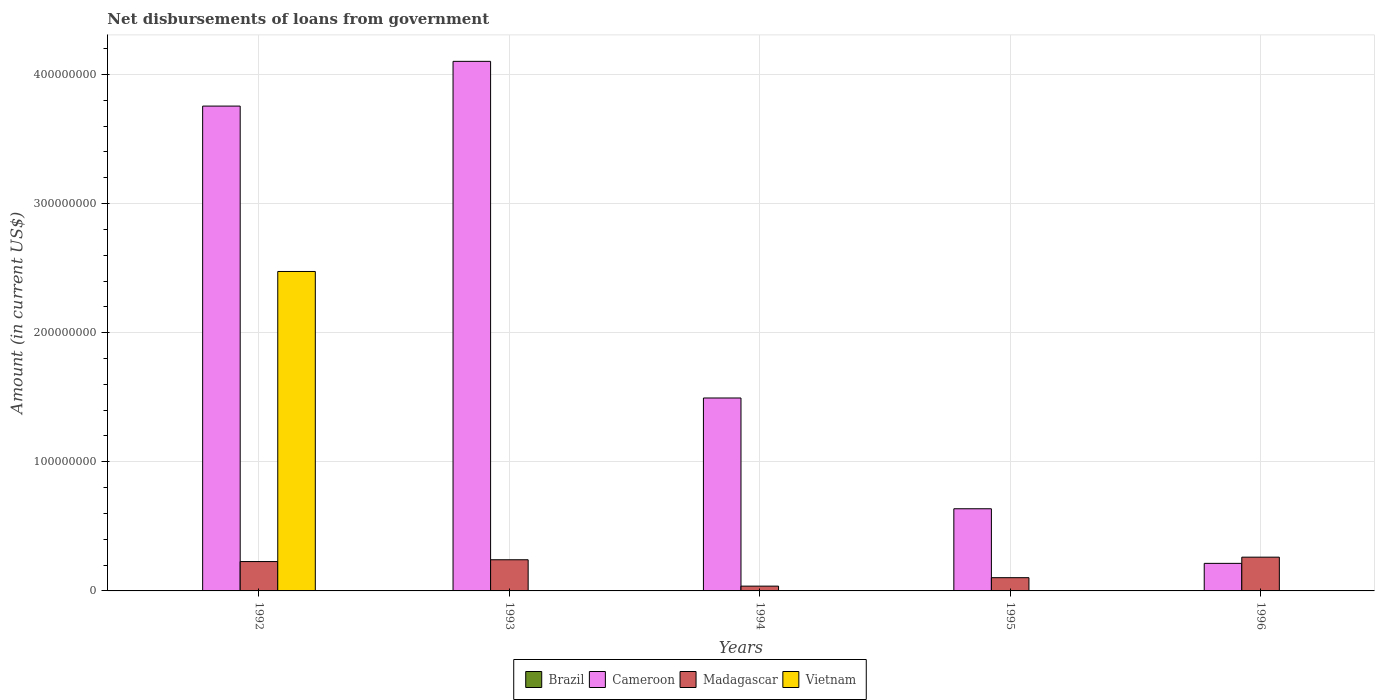Are the number of bars per tick equal to the number of legend labels?
Ensure brevity in your answer.  No. How many bars are there on the 4th tick from the left?
Provide a short and direct response. 2. How many bars are there on the 3rd tick from the right?
Keep it short and to the point. 2. What is the label of the 5th group of bars from the left?
Provide a succinct answer. 1996. In how many cases, is the number of bars for a given year not equal to the number of legend labels?
Provide a succinct answer. 5. What is the amount of loan disbursed from government in Madagascar in 1996?
Keep it short and to the point. 2.61e+07. Across all years, what is the maximum amount of loan disbursed from government in Vietnam?
Your response must be concise. 2.47e+08. Across all years, what is the minimum amount of loan disbursed from government in Brazil?
Offer a terse response. 0. In which year was the amount of loan disbursed from government in Vietnam maximum?
Make the answer very short. 1992. What is the total amount of loan disbursed from government in Vietnam in the graph?
Provide a succinct answer. 2.47e+08. What is the difference between the amount of loan disbursed from government in Cameroon in 1994 and that in 1995?
Give a very brief answer. 8.58e+07. What is the difference between the amount of loan disbursed from government in Cameroon in 1992 and the amount of loan disbursed from government in Vietnam in 1996?
Your response must be concise. 3.75e+08. What is the average amount of loan disbursed from government in Cameroon per year?
Your answer should be very brief. 2.04e+08. In the year 1992, what is the difference between the amount of loan disbursed from government in Cameroon and amount of loan disbursed from government in Vietnam?
Your response must be concise. 1.28e+08. What is the ratio of the amount of loan disbursed from government in Cameroon in 1992 to that in 1996?
Your response must be concise. 17.6. What is the difference between the highest and the second highest amount of loan disbursed from government in Madagascar?
Give a very brief answer. 2.00e+06. What is the difference between the highest and the lowest amount of loan disbursed from government in Cameroon?
Offer a terse response. 3.89e+08. In how many years, is the amount of loan disbursed from government in Vietnam greater than the average amount of loan disbursed from government in Vietnam taken over all years?
Provide a succinct answer. 1. Is it the case that in every year, the sum of the amount of loan disbursed from government in Vietnam and amount of loan disbursed from government in Brazil is greater than the amount of loan disbursed from government in Madagascar?
Your response must be concise. No. How many bars are there?
Make the answer very short. 11. Are all the bars in the graph horizontal?
Provide a short and direct response. No. How many years are there in the graph?
Give a very brief answer. 5. What is the difference between two consecutive major ticks on the Y-axis?
Provide a short and direct response. 1.00e+08. Does the graph contain any zero values?
Ensure brevity in your answer.  Yes. How are the legend labels stacked?
Your answer should be compact. Horizontal. What is the title of the graph?
Your answer should be very brief. Net disbursements of loans from government. What is the label or title of the X-axis?
Make the answer very short. Years. What is the Amount (in current US$) of Cameroon in 1992?
Keep it short and to the point. 3.75e+08. What is the Amount (in current US$) in Madagascar in 1992?
Keep it short and to the point. 2.27e+07. What is the Amount (in current US$) in Vietnam in 1992?
Give a very brief answer. 2.47e+08. What is the Amount (in current US$) of Brazil in 1993?
Keep it short and to the point. 0. What is the Amount (in current US$) in Cameroon in 1993?
Keep it short and to the point. 4.10e+08. What is the Amount (in current US$) in Madagascar in 1993?
Provide a short and direct response. 2.41e+07. What is the Amount (in current US$) of Cameroon in 1994?
Your answer should be very brief. 1.49e+08. What is the Amount (in current US$) in Madagascar in 1994?
Provide a succinct answer. 3.71e+06. What is the Amount (in current US$) in Vietnam in 1994?
Ensure brevity in your answer.  0. What is the Amount (in current US$) of Brazil in 1995?
Offer a terse response. 0. What is the Amount (in current US$) in Cameroon in 1995?
Your answer should be very brief. 6.36e+07. What is the Amount (in current US$) in Madagascar in 1995?
Your answer should be compact. 1.02e+07. What is the Amount (in current US$) in Vietnam in 1995?
Give a very brief answer. 0. What is the Amount (in current US$) in Brazil in 1996?
Give a very brief answer. 0. What is the Amount (in current US$) in Cameroon in 1996?
Ensure brevity in your answer.  2.13e+07. What is the Amount (in current US$) of Madagascar in 1996?
Give a very brief answer. 2.61e+07. What is the Amount (in current US$) of Vietnam in 1996?
Your answer should be very brief. 0. Across all years, what is the maximum Amount (in current US$) in Cameroon?
Keep it short and to the point. 4.10e+08. Across all years, what is the maximum Amount (in current US$) in Madagascar?
Keep it short and to the point. 2.61e+07. Across all years, what is the maximum Amount (in current US$) of Vietnam?
Your answer should be very brief. 2.47e+08. Across all years, what is the minimum Amount (in current US$) of Cameroon?
Your response must be concise. 2.13e+07. Across all years, what is the minimum Amount (in current US$) of Madagascar?
Ensure brevity in your answer.  3.71e+06. Across all years, what is the minimum Amount (in current US$) in Vietnam?
Keep it short and to the point. 0. What is the total Amount (in current US$) of Cameroon in the graph?
Make the answer very short. 1.02e+09. What is the total Amount (in current US$) in Madagascar in the graph?
Provide a succinct answer. 8.70e+07. What is the total Amount (in current US$) in Vietnam in the graph?
Provide a short and direct response. 2.47e+08. What is the difference between the Amount (in current US$) in Cameroon in 1992 and that in 1993?
Ensure brevity in your answer.  -3.46e+07. What is the difference between the Amount (in current US$) in Madagascar in 1992 and that in 1993?
Provide a succinct answer. -1.39e+06. What is the difference between the Amount (in current US$) in Cameroon in 1992 and that in 1994?
Your answer should be compact. 2.26e+08. What is the difference between the Amount (in current US$) of Madagascar in 1992 and that in 1994?
Offer a very short reply. 1.90e+07. What is the difference between the Amount (in current US$) in Cameroon in 1992 and that in 1995?
Make the answer very short. 3.12e+08. What is the difference between the Amount (in current US$) in Madagascar in 1992 and that in 1995?
Provide a short and direct response. 1.25e+07. What is the difference between the Amount (in current US$) in Cameroon in 1992 and that in 1996?
Offer a terse response. 3.54e+08. What is the difference between the Amount (in current US$) in Madagascar in 1992 and that in 1996?
Your answer should be compact. -3.39e+06. What is the difference between the Amount (in current US$) of Cameroon in 1993 and that in 1994?
Your answer should be very brief. 2.61e+08. What is the difference between the Amount (in current US$) in Madagascar in 1993 and that in 1994?
Provide a succinct answer. 2.04e+07. What is the difference between the Amount (in current US$) in Cameroon in 1993 and that in 1995?
Offer a very short reply. 3.46e+08. What is the difference between the Amount (in current US$) in Madagascar in 1993 and that in 1995?
Your response must be concise. 1.39e+07. What is the difference between the Amount (in current US$) in Cameroon in 1993 and that in 1996?
Give a very brief answer. 3.89e+08. What is the difference between the Amount (in current US$) of Madagascar in 1993 and that in 1996?
Make the answer very short. -2.00e+06. What is the difference between the Amount (in current US$) in Cameroon in 1994 and that in 1995?
Your response must be concise. 8.58e+07. What is the difference between the Amount (in current US$) in Madagascar in 1994 and that in 1995?
Ensure brevity in your answer.  -6.54e+06. What is the difference between the Amount (in current US$) in Cameroon in 1994 and that in 1996?
Offer a very short reply. 1.28e+08. What is the difference between the Amount (in current US$) in Madagascar in 1994 and that in 1996?
Make the answer very short. -2.24e+07. What is the difference between the Amount (in current US$) of Cameroon in 1995 and that in 1996?
Offer a terse response. 4.23e+07. What is the difference between the Amount (in current US$) of Madagascar in 1995 and that in 1996?
Offer a terse response. -1.59e+07. What is the difference between the Amount (in current US$) in Cameroon in 1992 and the Amount (in current US$) in Madagascar in 1993?
Your response must be concise. 3.51e+08. What is the difference between the Amount (in current US$) of Cameroon in 1992 and the Amount (in current US$) of Madagascar in 1994?
Provide a succinct answer. 3.72e+08. What is the difference between the Amount (in current US$) of Cameroon in 1992 and the Amount (in current US$) of Madagascar in 1995?
Your answer should be compact. 3.65e+08. What is the difference between the Amount (in current US$) in Cameroon in 1992 and the Amount (in current US$) in Madagascar in 1996?
Give a very brief answer. 3.49e+08. What is the difference between the Amount (in current US$) in Cameroon in 1993 and the Amount (in current US$) in Madagascar in 1994?
Give a very brief answer. 4.06e+08. What is the difference between the Amount (in current US$) in Cameroon in 1993 and the Amount (in current US$) in Madagascar in 1995?
Your answer should be very brief. 4.00e+08. What is the difference between the Amount (in current US$) in Cameroon in 1993 and the Amount (in current US$) in Madagascar in 1996?
Ensure brevity in your answer.  3.84e+08. What is the difference between the Amount (in current US$) of Cameroon in 1994 and the Amount (in current US$) of Madagascar in 1995?
Keep it short and to the point. 1.39e+08. What is the difference between the Amount (in current US$) of Cameroon in 1994 and the Amount (in current US$) of Madagascar in 1996?
Offer a terse response. 1.23e+08. What is the difference between the Amount (in current US$) in Cameroon in 1995 and the Amount (in current US$) in Madagascar in 1996?
Your answer should be compact. 3.75e+07. What is the average Amount (in current US$) in Cameroon per year?
Offer a terse response. 2.04e+08. What is the average Amount (in current US$) in Madagascar per year?
Your answer should be very brief. 1.74e+07. What is the average Amount (in current US$) of Vietnam per year?
Your answer should be compact. 4.95e+07. In the year 1992, what is the difference between the Amount (in current US$) in Cameroon and Amount (in current US$) in Madagascar?
Your answer should be very brief. 3.53e+08. In the year 1992, what is the difference between the Amount (in current US$) in Cameroon and Amount (in current US$) in Vietnam?
Keep it short and to the point. 1.28e+08. In the year 1992, what is the difference between the Amount (in current US$) in Madagascar and Amount (in current US$) in Vietnam?
Ensure brevity in your answer.  -2.25e+08. In the year 1993, what is the difference between the Amount (in current US$) in Cameroon and Amount (in current US$) in Madagascar?
Your answer should be compact. 3.86e+08. In the year 1994, what is the difference between the Amount (in current US$) in Cameroon and Amount (in current US$) in Madagascar?
Provide a short and direct response. 1.46e+08. In the year 1995, what is the difference between the Amount (in current US$) in Cameroon and Amount (in current US$) in Madagascar?
Give a very brief answer. 5.34e+07. In the year 1996, what is the difference between the Amount (in current US$) in Cameroon and Amount (in current US$) in Madagascar?
Give a very brief answer. -4.80e+06. What is the ratio of the Amount (in current US$) of Cameroon in 1992 to that in 1993?
Give a very brief answer. 0.92. What is the ratio of the Amount (in current US$) of Madagascar in 1992 to that in 1993?
Your answer should be compact. 0.94. What is the ratio of the Amount (in current US$) in Cameroon in 1992 to that in 1994?
Ensure brevity in your answer.  2.51. What is the ratio of the Amount (in current US$) in Madagascar in 1992 to that in 1994?
Your answer should be very brief. 6.13. What is the ratio of the Amount (in current US$) in Cameroon in 1992 to that in 1995?
Your answer should be very brief. 5.9. What is the ratio of the Amount (in current US$) in Madagascar in 1992 to that in 1995?
Keep it short and to the point. 2.22. What is the ratio of the Amount (in current US$) in Cameroon in 1992 to that in 1996?
Your response must be concise. 17.6. What is the ratio of the Amount (in current US$) of Madagascar in 1992 to that in 1996?
Make the answer very short. 0.87. What is the ratio of the Amount (in current US$) in Cameroon in 1993 to that in 1994?
Your answer should be very brief. 2.75. What is the ratio of the Amount (in current US$) in Madagascar in 1993 to that in 1994?
Offer a very short reply. 6.51. What is the ratio of the Amount (in current US$) of Cameroon in 1993 to that in 1995?
Make the answer very short. 6.45. What is the ratio of the Amount (in current US$) in Madagascar in 1993 to that in 1995?
Provide a short and direct response. 2.35. What is the ratio of the Amount (in current US$) of Cameroon in 1993 to that in 1996?
Your response must be concise. 19.22. What is the ratio of the Amount (in current US$) of Madagascar in 1993 to that in 1996?
Provide a succinct answer. 0.92. What is the ratio of the Amount (in current US$) of Cameroon in 1994 to that in 1995?
Offer a very short reply. 2.35. What is the ratio of the Amount (in current US$) in Madagascar in 1994 to that in 1995?
Make the answer very short. 0.36. What is the ratio of the Amount (in current US$) in Cameroon in 1994 to that in 1996?
Provide a short and direct response. 7. What is the ratio of the Amount (in current US$) in Madagascar in 1994 to that in 1996?
Give a very brief answer. 0.14. What is the ratio of the Amount (in current US$) in Cameroon in 1995 to that in 1996?
Provide a short and direct response. 2.98. What is the ratio of the Amount (in current US$) of Madagascar in 1995 to that in 1996?
Keep it short and to the point. 0.39. What is the difference between the highest and the second highest Amount (in current US$) of Cameroon?
Your answer should be compact. 3.46e+07. What is the difference between the highest and the second highest Amount (in current US$) of Madagascar?
Keep it short and to the point. 2.00e+06. What is the difference between the highest and the lowest Amount (in current US$) of Cameroon?
Make the answer very short. 3.89e+08. What is the difference between the highest and the lowest Amount (in current US$) in Madagascar?
Give a very brief answer. 2.24e+07. What is the difference between the highest and the lowest Amount (in current US$) in Vietnam?
Offer a terse response. 2.47e+08. 